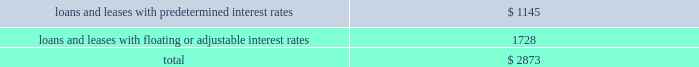We define past-due loans as loans on which contractual principal or interest payments are over 90 days delinquent , but for which interest continues to be accrued .
No institutional loans were 90 days or more contractually past due as of december 31 , 2011 , 2010 , 2009 , 2008 or 2007 .
Although a portion of the cre loans was 90 days or more contractually past due as of december 31 , 2011 , 2010 , 2009 and 2008 , we do not report them as past-due loans , because in accordance with gaap , the interest earned on these loans is based on an accretable yield resulting from management 2019s expectations with respect to the future cash flows for each loan relative to both the timing and collection of principal and interest as of the reporting date , not the loans 2019 contractual payment terms .
These cash flow estimates are updated quarterly to reflect changes in management 2019s expectations , which consider market conditions .
We generally place loans on non-accrual status once principal or interest payments are 60 days past due , or earlier if management determines that full collection is not probable .
Loans 60 days past due , but considered both well-secured and in the process of collection , may be excluded from non-accrual status .
For loans placed on non-accrual status , revenue recognition is suspended .
As of december 31 , 2011 and 2010 , approximately $ 5 million and $ 158 million , respectively , of the aforementioned cre loans had been placed by management on non-accrual status , as the yield associated with these loans , determined when the loans were acquired , was deemed to be non-accretable .
This determination was based on management 2019s expectations of the future collection of principal and interest from the loans .
The decline in loans on non-accrual status at december 31 , 2011 compared to december 31 , 2010 resulted mainly from the transfer of certain cre loans to other real estate owned in 2011 in connection with foreclosure or similar transactions .
These transactions had no impact on our 2011 consolidated statement of income .
The table presents contractual maturities for loan and lease balances as of december 31 , 2011 : ( in millions ) total under 1 year 1 to 5 years over 5 years institutional : investment funds : u.s .
$ 5592 $ 5261 $ 331 non-u.s .
796 796 2014 commercial and financial : u.s .
563 533 30 non-u.s .
453 440 13 purchased receivables : u.s .
563 2014 49 $ 514 non-u.s .
372 2014 372 2014 lease financing : u.s .
397 9 39 349 non-u.s .
857 100 217 540 total institutional .
9593 7139 1051 1403 commercial real estate : u.s .
460 41 21 398 total loans and leases .
$ 10053 $ 7180 $ 1072 $ 1801 the table presents the classification of loan and lease balances due after one year according to sensitivity to changes in interest rates as of december 31 , 2011 : ( in millions ) .

What was the percent of the classification of loan and lease balances due after one year that was loans and leases with predetermined interest rates? 
Computations: (1145 / 2873)
Answer: 0.39854. 